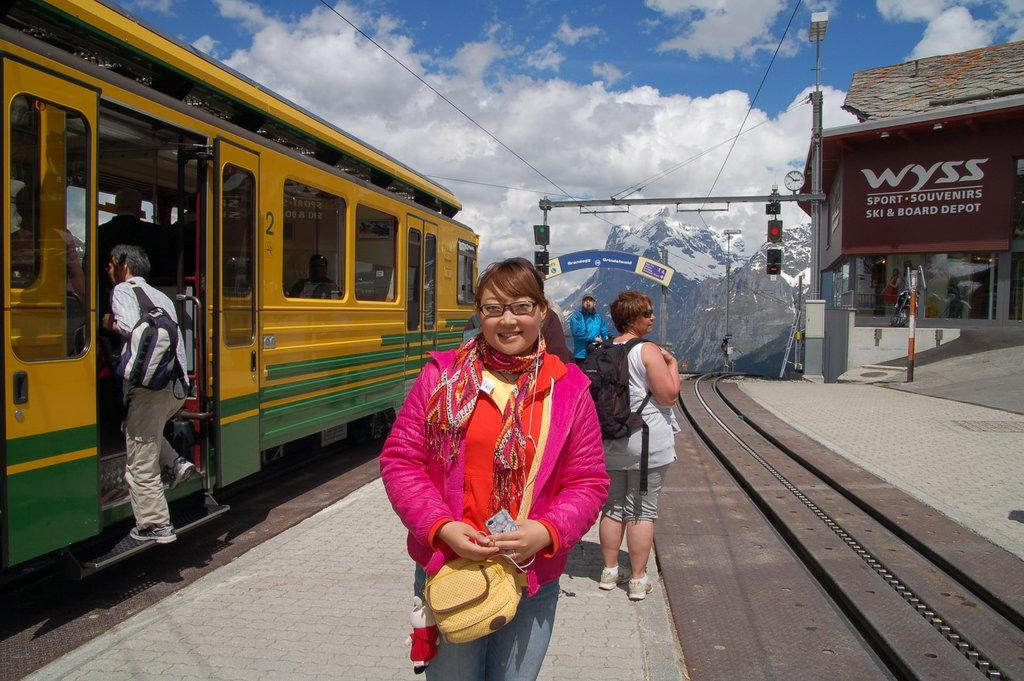What is the main subject in the image? There is a woman standing in the image. What can be seen on the left side of the image? There is a train on the left side of the image. What is visible in the background of the image? There are clouds in the sky in the background of the image. What type of decision is the boat making in the image? There is no boat present in the image, so it is not possible to answer that question. 